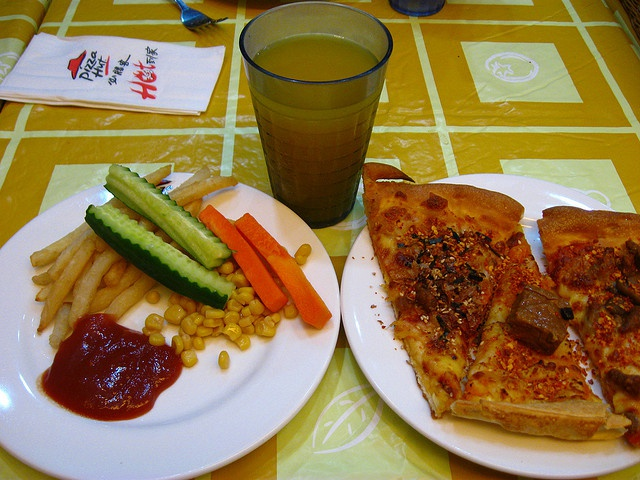Describe the objects in this image and their specific colors. I can see dining table in olive, maroon, and lavender tones, pizza in olive, brown, maroon, and black tones, cup in olive, maroon, black, and gray tones, pizza in olive, maroon, brown, and black tones, and carrot in olive, red, and brown tones in this image. 